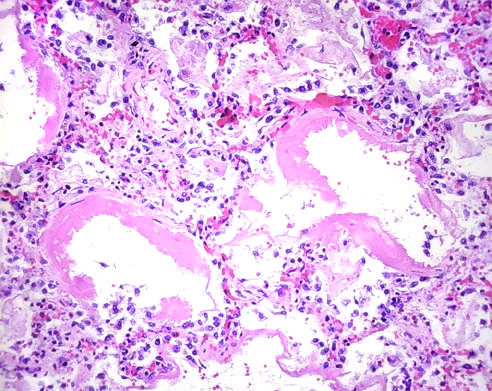s a prolymphocyte, a larger cell with a centrally placed nucleolus, lined by bright pink hyaline membranes?
Answer the question using a single word or phrase. No 